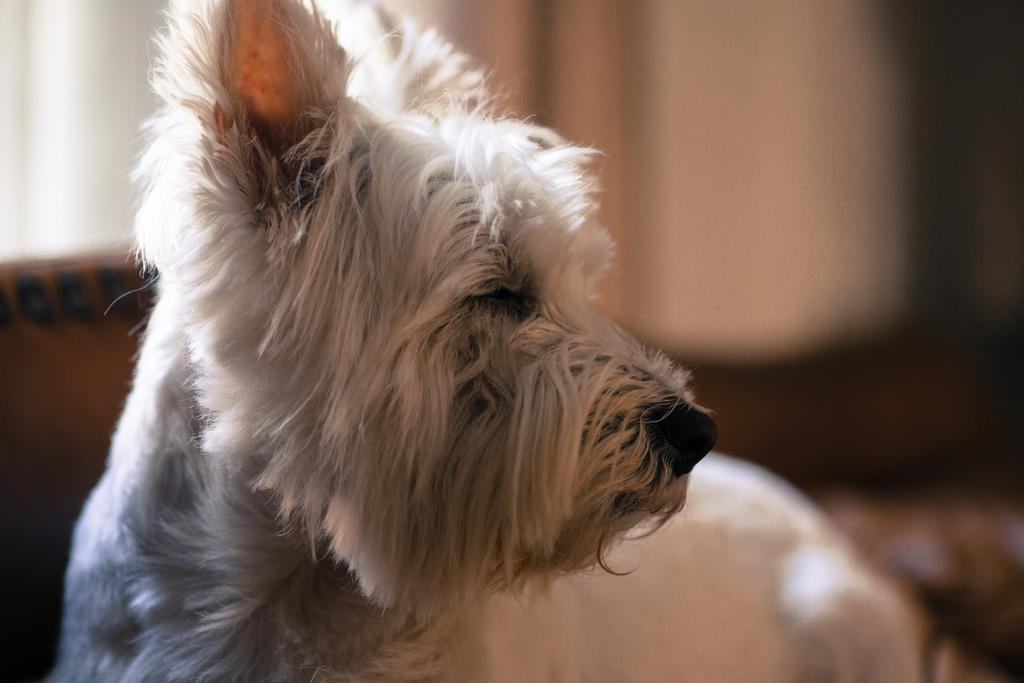What type of animal is present in the image? There is an animal in the image, but the specific type cannot be determined from the provided facts. Can you describe the background of the image? The background of the image contains objects, but their nature cannot be determined from the provided facts. What type of jar is visible on the animal's head in the image? There is no jar present on the animal's head in the image. What type of apparel is the animal wearing in the image? There is no apparel visible on the animal in the image. 